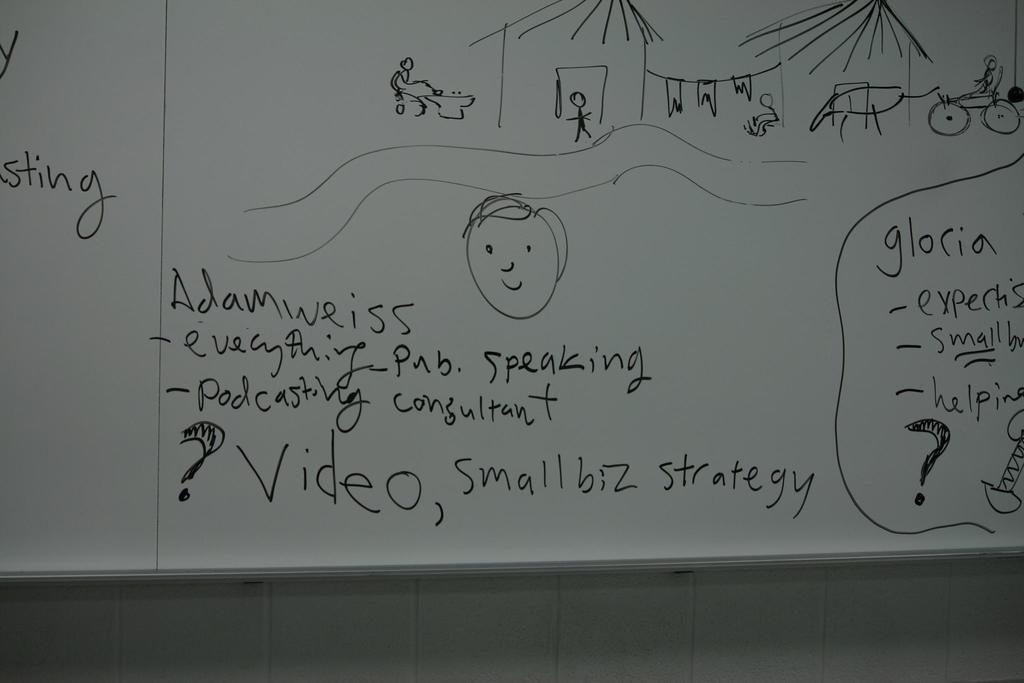<image>
Share a concise interpretation of the image provided. A dry erase white board has an image of homes with people, horses and carriages outside of them, above bullet point ideas for small businesses. 